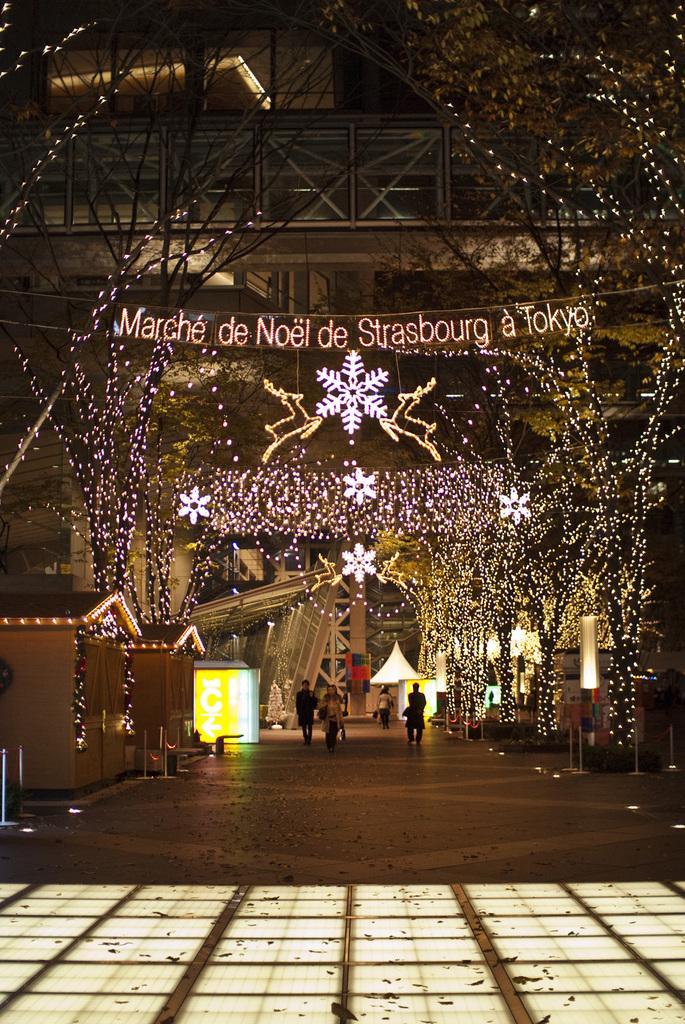Please provide a concise description of this image. In the image I can see trees which are decorated with string lights. I can also see people walking on the ground. In the background I can see a building, led board, lights and some other objects on the ground. 